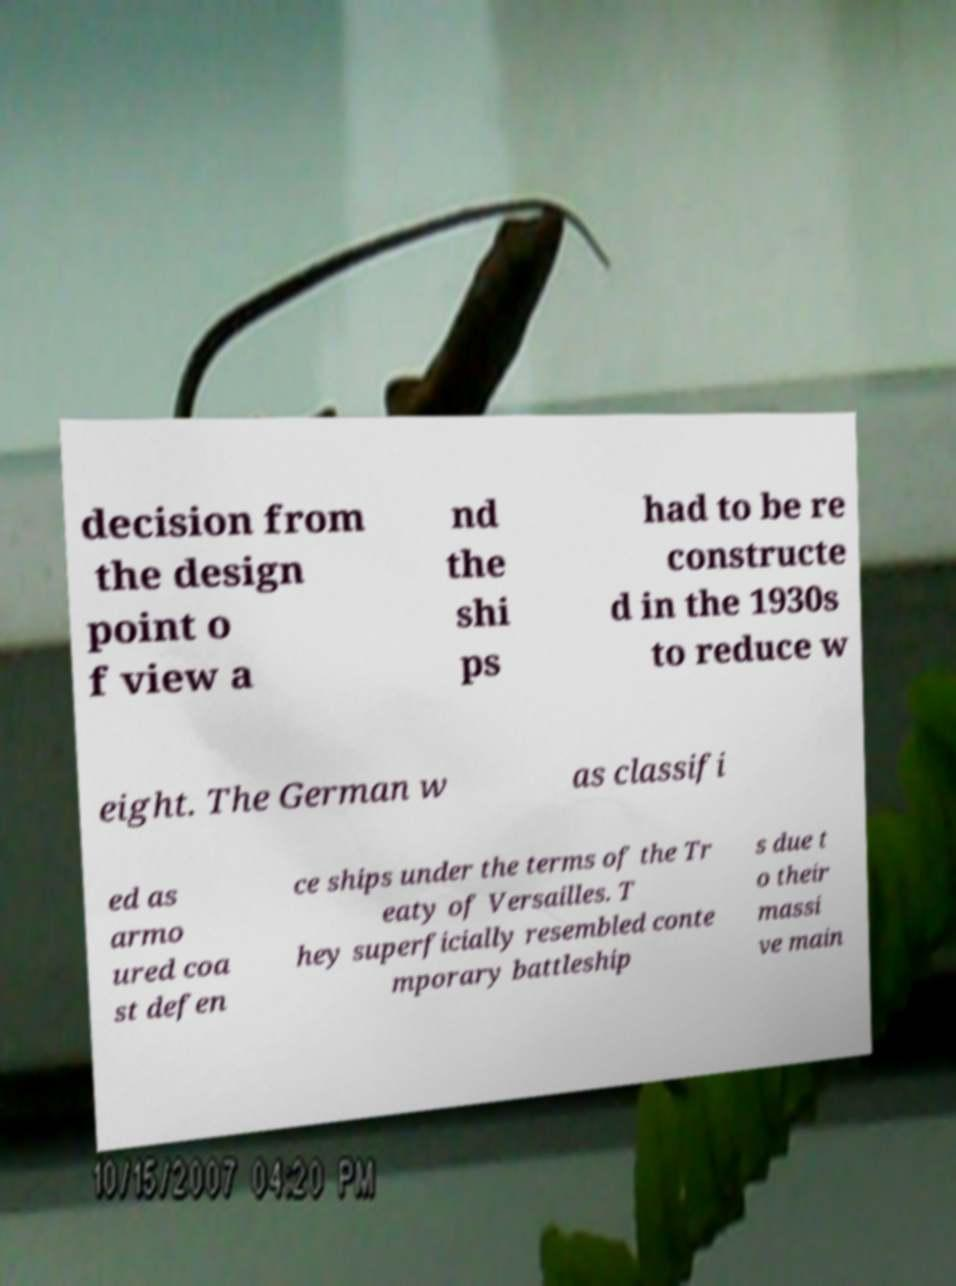Please read and relay the text visible in this image. What does it say? decision from the design point o f view a nd the shi ps had to be re constructe d in the 1930s to reduce w eight. The German w as classifi ed as armo ured coa st defen ce ships under the terms of the Tr eaty of Versailles. T hey superficially resembled conte mporary battleship s due t o their massi ve main 